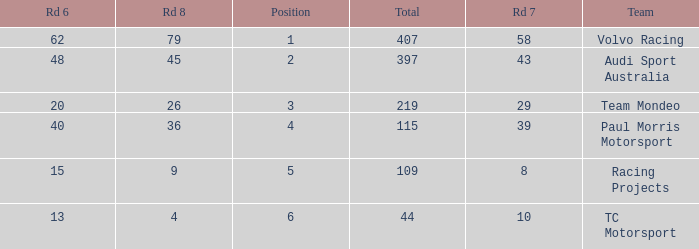What is the average value for Rd 8 in a position less than 2 for Audi Sport Australia? None. 